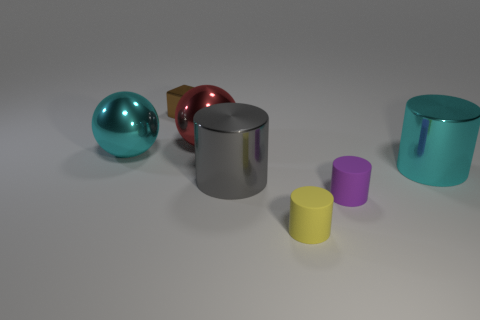Add 2 rubber cylinders. How many objects exist? 9 Subtract all small purple matte cylinders. How many cylinders are left? 3 Subtract 1 cylinders. How many cylinders are left? 3 Add 5 small brown metal objects. How many small brown metal objects exist? 6 Subtract all cyan cylinders. How many cylinders are left? 3 Subtract 1 gray cylinders. How many objects are left? 6 Subtract all cylinders. How many objects are left? 3 Subtract all blue balls. Subtract all brown blocks. How many balls are left? 2 Subtract all purple cylinders. How many blue balls are left? 0 Subtract all big gray cylinders. Subtract all large gray cylinders. How many objects are left? 5 